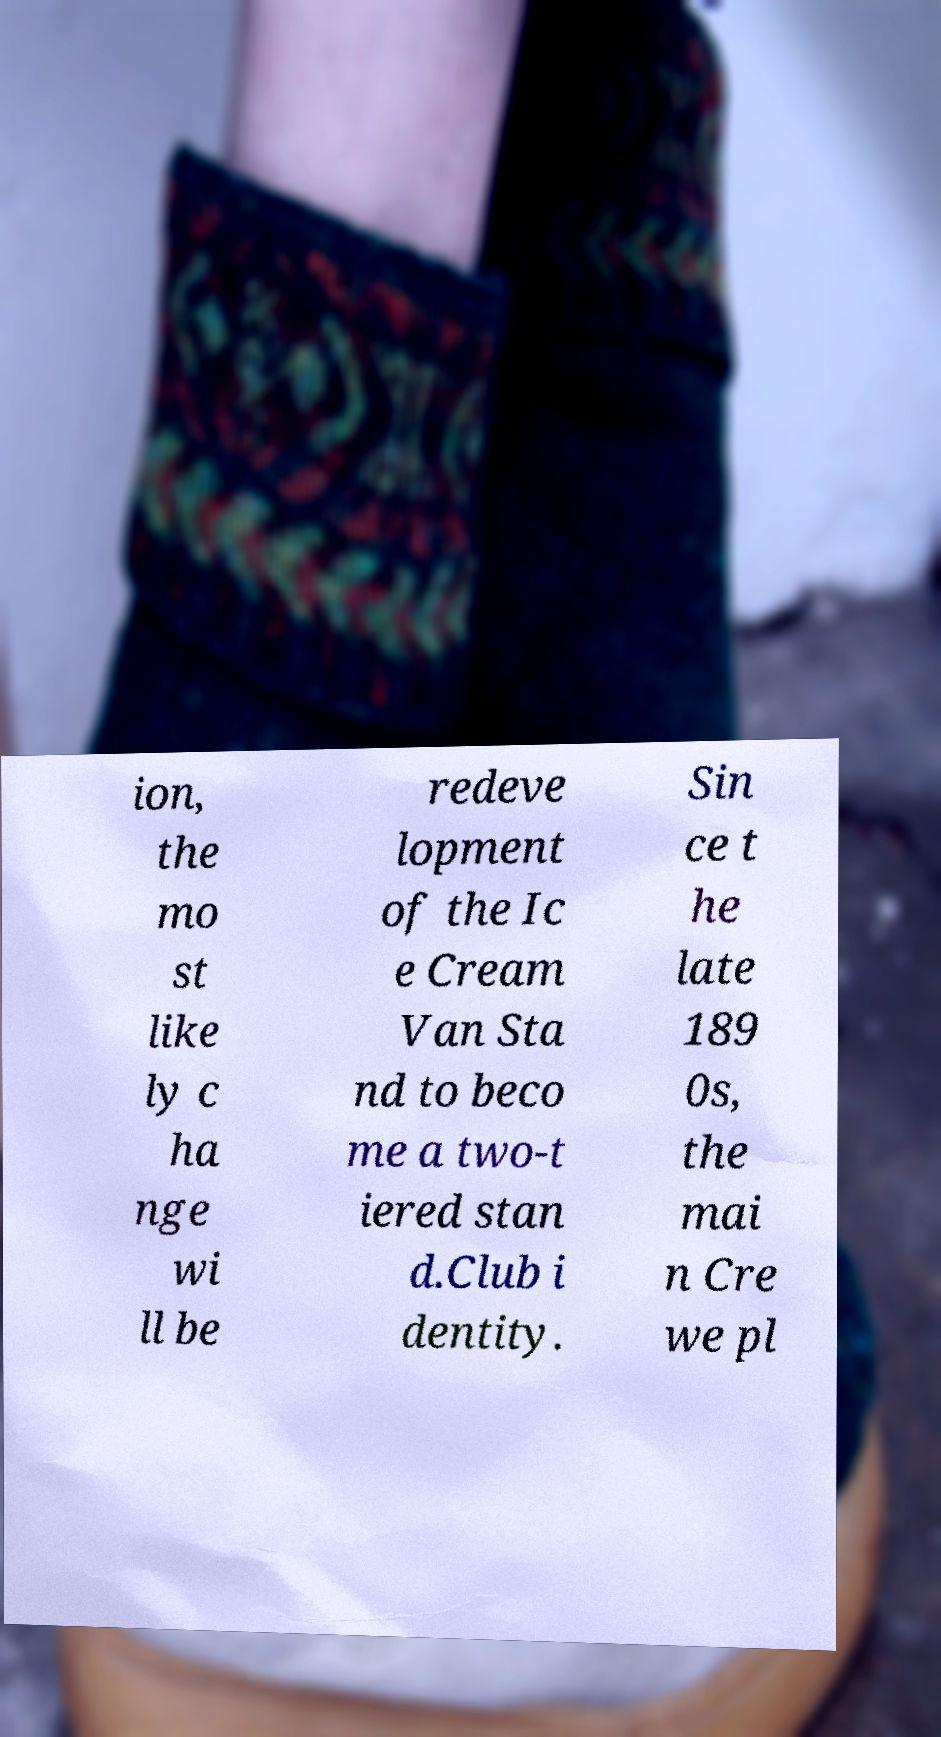Please read and relay the text visible in this image. What does it say? ion, the mo st like ly c ha nge wi ll be redeve lopment of the Ic e Cream Van Sta nd to beco me a two-t iered stan d.Club i dentity. Sin ce t he late 189 0s, the mai n Cre we pl 